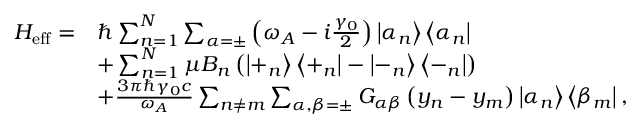<formula> <loc_0><loc_0><loc_500><loc_500>\begin{array} { r l } { H _ { e f f } = } & { \hbar { \sum } _ { n = 1 } ^ { N } \sum _ { \alpha = \pm } \left ( \omega _ { A } - i \frac { \gamma _ { 0 } } { 2 } \right ) \left | \alpha _ { n } \right \rangle \left \langle \alpha _ { n } \right | } \\ & { + \sum _ { n = 1 } ^ { N } \mu B _ { n } \left ( \left | + _ { n } \right \rangle \left \langle + _ { n } \right | - \left | - _ { n } \right \rangle \left \langle - _ { n } \right | \right ) } \\ & { + \frac { 3 \pi \hbar { \gamma } _ { 0 } c } { \omega _ { A } } \sum _ { n \neq m } \sum _ { \alpha , \beta = \pm } G _ { \alpha \beta } \left ( y _ { n } - y _ { m } \right ) \left | \alpha _ { n } \right \rangle \left \langle \beta _ { m } \right | , } \end{array}</formula> 